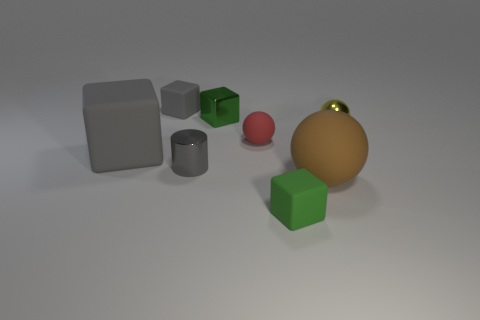Do the yellow ball and the brown object have the same size?
Ensure brevity in your answer.  No. The small green thing that is behind the block that is to the right of the tiny green block that is behind the shiny ball is what shape?
Your answer should be very brief. Cube. What is the color of the other rubber object that is the same shape as the brown object?
Your answer should be very brief. Red. What is the size of the matte thing that is both behind the big matte sphere and in front of the red sphere?
Give a very brief answer. Large. There is a tiny matte cube that is behind the rubber ball behind the gray metallic object; how many things are on the left side of it?
Offer a very short reply. 1. How many tiny things are either brown matte balls or yellow cubes?
Give a very brief answer. 0. Are the tiny block left of the tiny green metallic object and the large brown sphere made of the same material?
Offer a terse response. Yes. What is the small block that is in front of the small gray object that is in front of the tiny rubber block behind the red ball made of?
Make the answer very short. Rubber. Are there any other things that have the same size as the red matte sphere?
Keep it short and to the point. Yes. What number of metal things are small green cubes or small yellow balls?
Provide a short and direct response. 2. 